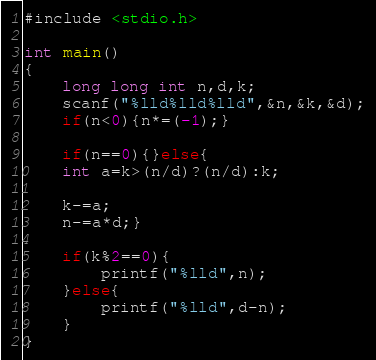<code> <loc_0><loc_0><loc_500><loc_500><_C_>#include <stdio.h>

int main()
{
	long long int n,d,k;
	scanf("%lld%lld%lld",&n,&k,&d);
	if(n<0){n*=(-1);}
	
	if(n==0){}else{
	int a=k>(n/d)?(n/d):k;
	
	k-=a;
	n-=a*d;}
	
	if(k%2==0){
		printf("%lld",n);
	}else{
		printf("%lld",d-n);
	}
}</code> 